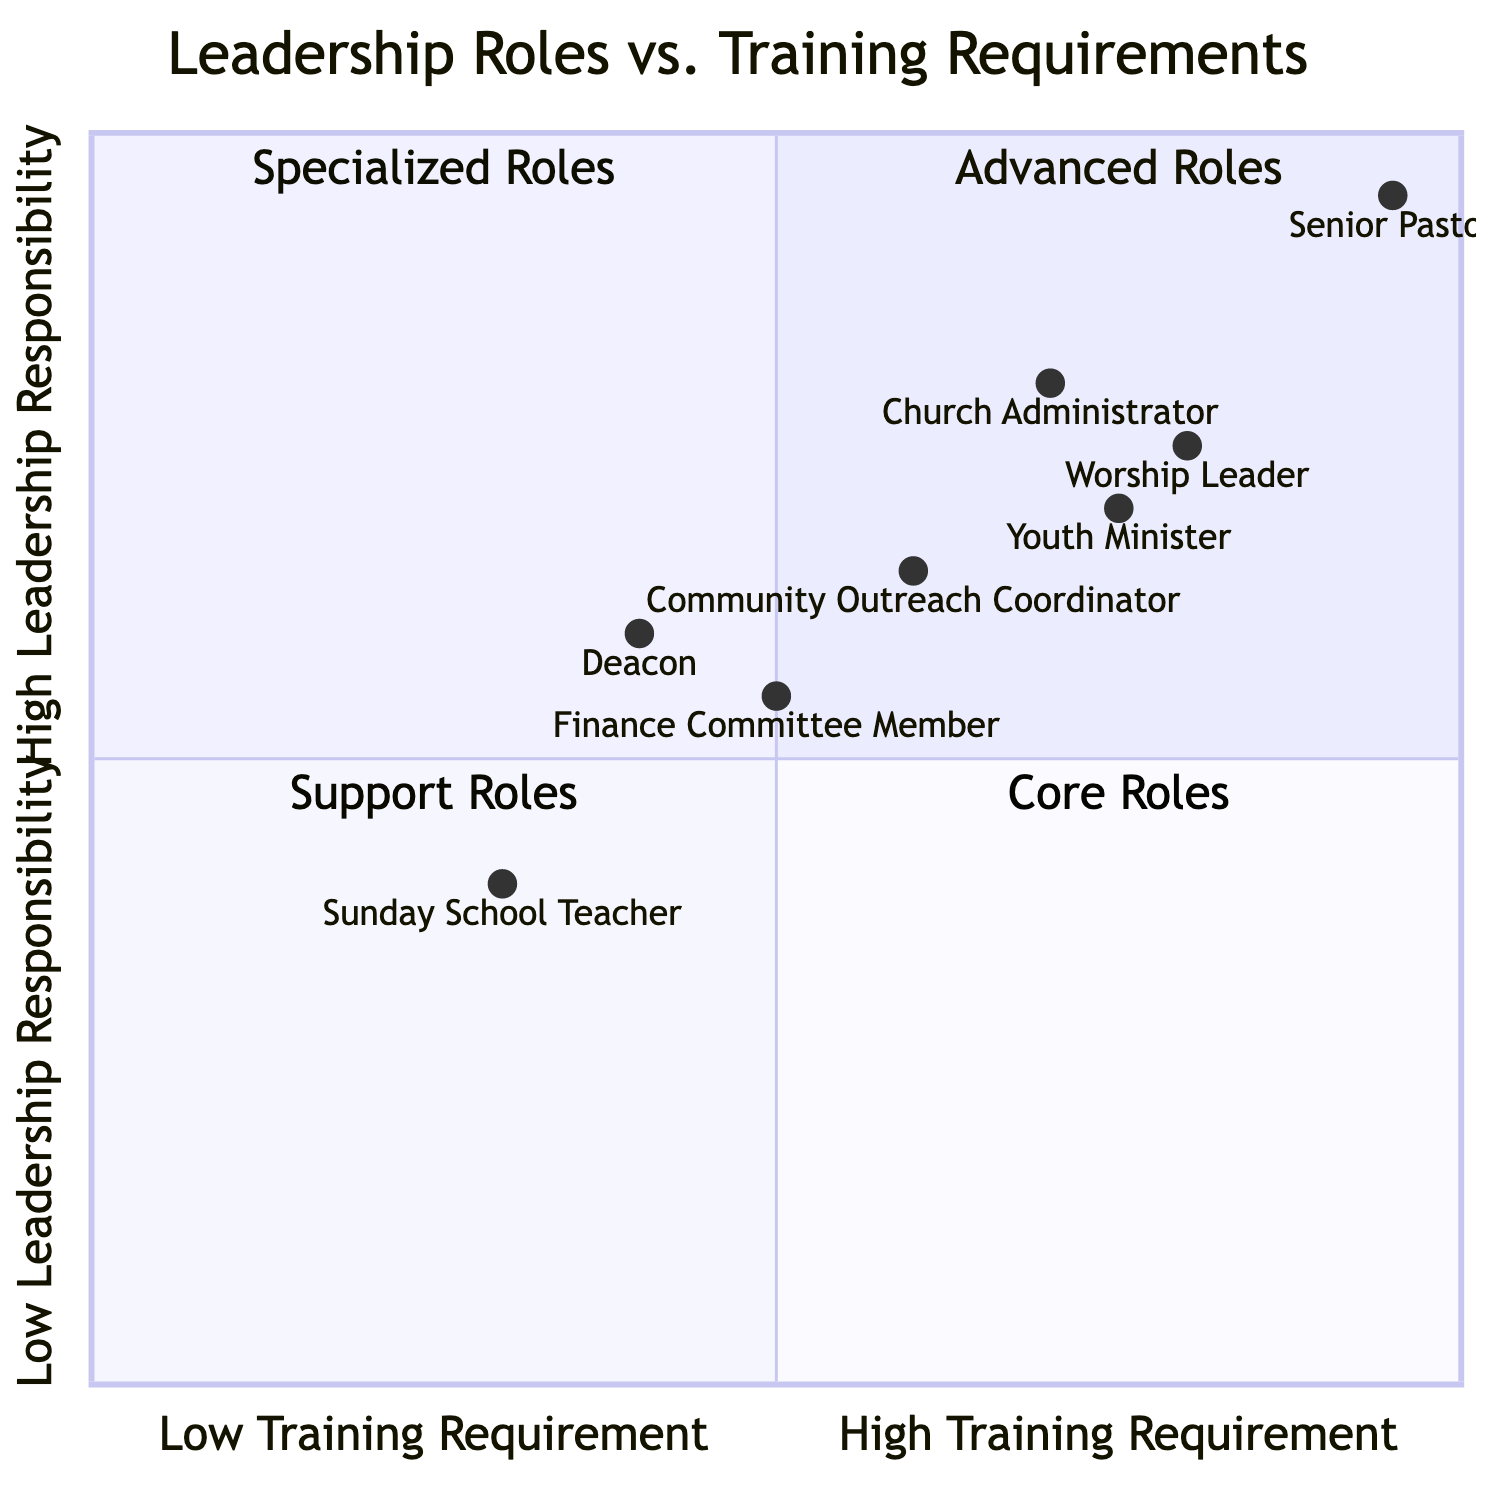What leadership role requires advanced theological education? The quadrant chart indicates that the "Senior Pastor" role is associated with "Advanced Theological Education," which is situated in the area representing high training requirement and high leadership responsibility.
Answer: Senior Pastor How many roles are classified in the Core Roles quadrant? The Core Roles quadrant is determined by those roles that have low training requirements and high leadership responsibility. From the data, "Sunday School Teacher" is the only role classified in this quadrant.
Answer: 1 Which role has the lowest training requirement? By examining the training requirements, the "Sunday School Teacher" role requires only "Basic Christian Education Training," which is the lowest listed compared to other roles.
Answer: Sunday School Teacher What is the relationship between the Worship Leader and the Youth Minister regarding training requirements? The chart shows that both the "Worship Leader" and "Youth Minister" are positioned in the Specialized Roles quadrant; however, the Worship Leader has a higher training requirement as indicated by their respective coordinates, which have a higher value on the x-axis than the Youth Minister.
Answer: The Worship Leader requires more training Which role has the highest training requirement? The "Senior Pastor" is positioned in the quadrant that indicates needing the most extensive training, with the highest training requirement being "Advanced Theological Education," making it the role with the highest training necessity.
Answer: Senior Pastor How many roles fall under Support Roles? The chart categorizes roles based on training requirements and leadership responsibility; the Support Roles quadrant includes "Deacon," "Finance Committee Member," and "Community Outreach Coordinator." Counting these three roles gives us the answer.
Answer: 3 Which leadership role has responsibilities associated with financial management? The role that oversees church finances and budget planning is "Finance Committee Member," which is specifically noted for requiring "Financial Management Training," making it the role connected to financial management responsibilities.
Answer: Finance Committee Member What training requirement does the Community Outreach Coordinator need? The chart specifies that the "Community Outreach Coordinator" requires "Social Work or Community Development Training," categorizing it under the relevant training requirement area.
Answer: Social Work or Community Development Training 